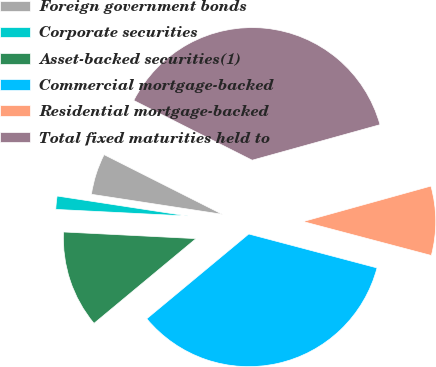Convert chart. <chart><loc_0><loc_0><loc_500><loc_500><pie_chart><fcel>Foreign government bonds<fcel>Corporate securities<fcel>Asset-backed securities(1)<fcel>Commercial mortgage-backed<fcel>Residential mortgage-backed<fcel>Total fixed maturities held to<nl><fcel>5.02%<fcel>1.62%<fcel>11.83%<fcel>34.85%<fcel>8.43%<fcel>38.25%<nl></chart> 